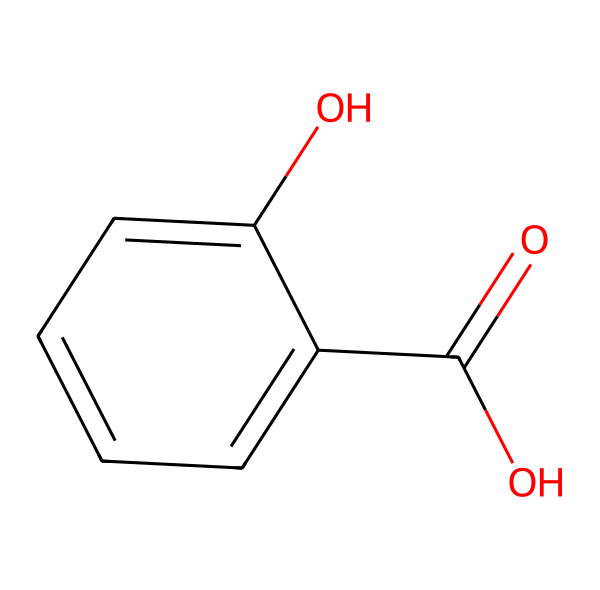What is the molecular formula of salicylic acid? The molecular formula is determined by counting the types and numbers of atoms present in the structure: The structure has 7 carbon (C) atoms, 6 hydrogen (H) atoms, and 3 oxygen (O) atoms, leading to the formula C7H6O3.
Answer: C7H6O3 How many hydroxyl (–OH) groups are present in salicylic acid? The chemical structure contains one –OH group directly attached to the benzene ring and another –OH group as part of the carboxylic acid (–COOH); thus, there are two hydroxyl groups.
Answer: 2 Which functional group indicates salicylic acid's acidity? The carboxylic acid group (–COOH), comprised of a carbonyl (C=O) and a hydroxyl (–OH), is the functional group that gives this compound its acidic properties.
Answer: carboxylic acid How many rings are in the molecular structure of salicylic acid? The molecular structure only features one benzene ring, which is a six-membered carbon ring with alternating double bonds. This is the only ring present.
Answer: 1 What kind of chemical is salicylic acid classified as? Salicylic acid is classified as a beta-hydroxy acid (BHA), commonly used for its exfoliating properties in cosmetic formulations. This classification is derived from its functional groups and structure.
Answer: beta-hydroxy acid What is the significance of the hydroxyl groups in salicylic acid for its cosmetic use? The hydroxyl groups contribute to both the exfoliating nature of salicylic acid through the process of keratolysis, breaking down dead skin cells, and its ability to help dissolve sebum, making it effective for acne-prone skin.
Answer: exfoliation 